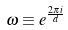Convert formula to latex. <formula><loc_0><loc_0><loc_500><loc_500>\omega \equiv e ^ { \frac { 2 \pi i } { d } }</formula> 